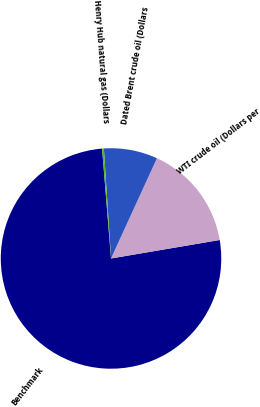Convert chart to OTSL. <chart><loc_0><loc_0><loc_500><loc_500><pie_chart><fcel>Benchmark<fcel>WTI crude oil (Dollars per<fcel>Dated Brent crude oil (Dollars<fcel>Henry Hub natural gas (Dollars<nl><fcel>76.38%<fcel>15.48%<fcel>7.87%<fcel>0.26%<nl></chart> 